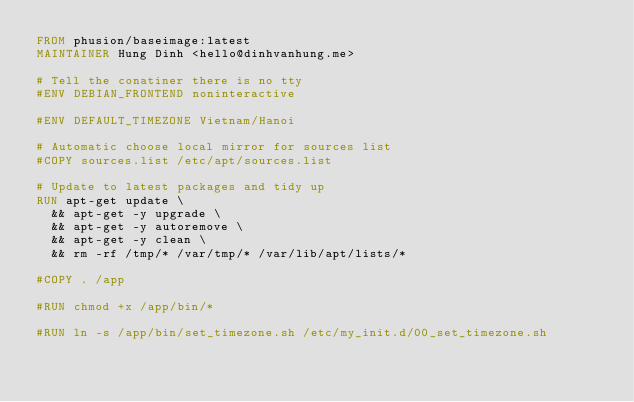<code> <loc_0><loc_0><loc_500><loc_500><_Dockerfile_>FROM phusion/baseimage:latest
MAINTAINER Hung Dinh <hello@dinhvanhung.me>

# Tell the conatiner there is no tty
#ENV DEBIAN_FRONTEND noninteractive

#ENV DEFAULT_TIMEZONE Vietnam/Hanoi

# Automatic choose local mirror for sources list
#COPY sources.list /etc/apt/sources.list

# Update to latest packages and tidy up
RUN apt-get update \
  && apt-get -y upgrade \
  && apt-get -y autoremove \
  && apt-get -y clean \
  && rm -rf /tmp/* /var/tmp/* /var/lib/apt/lists/* 

#COPY . /app

#RUN chmod +x /app/bin/*

#RUN ln -s /app/bin/set_timezone.sh /etc/my_init.d/00_set_timezone.sh
</code> 